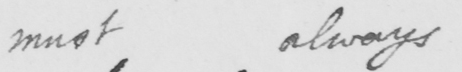What is written in this line of handwriting? must always 